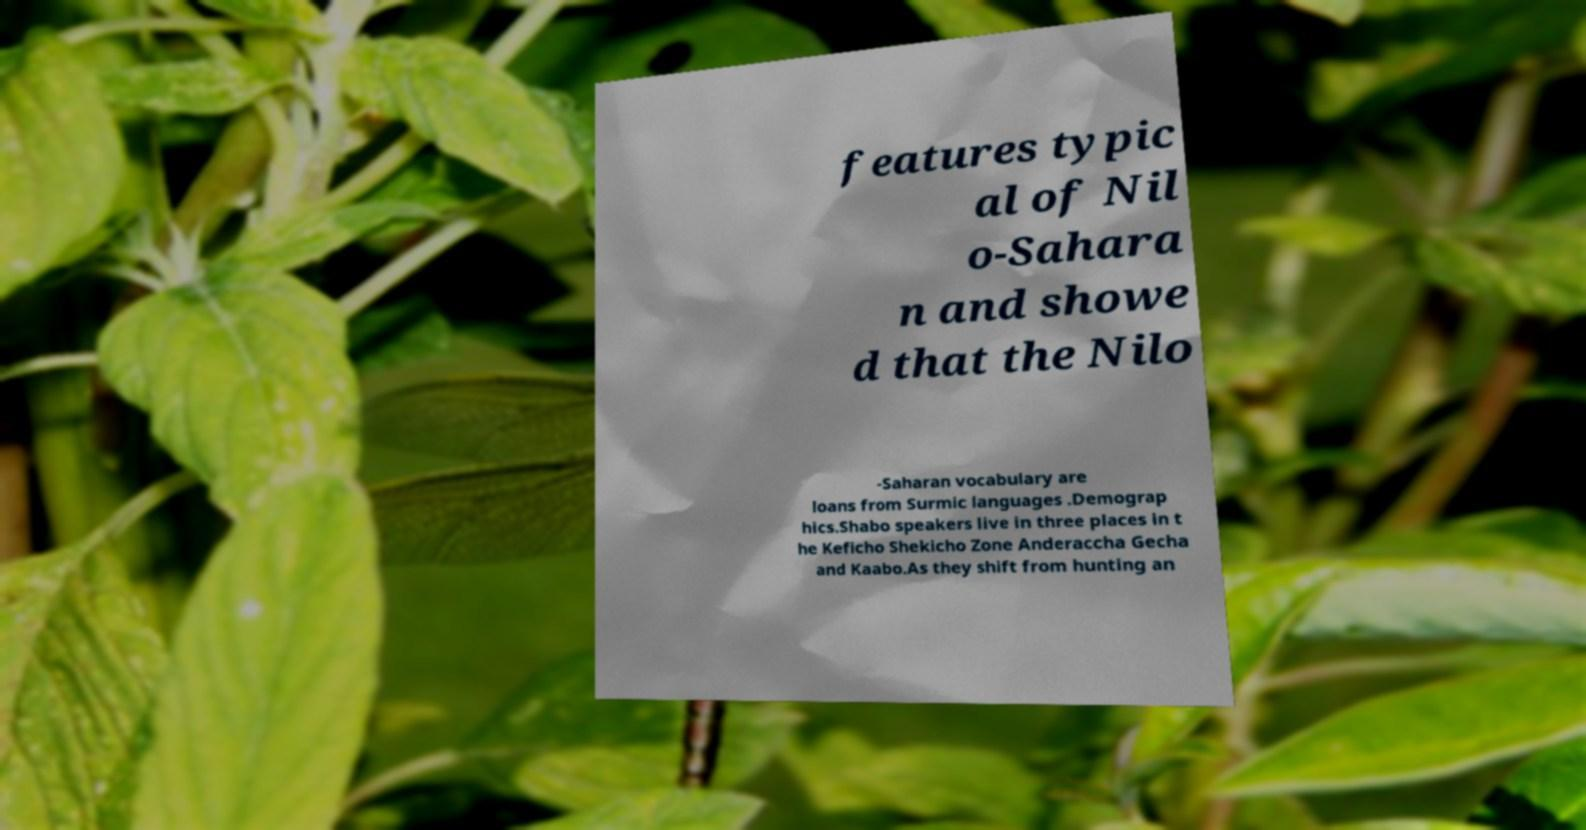Can you read and provide the text displayed in the image?This photo seems to have some interesting text. Can you extract and type it out for me? features typic al of Nil o-Sahara n and showe d that the Nilo -Saharan vocabulary are loans from Surmic languages .Demograp hics.Shabo speakers live in three places in t he Keficho Shekicho Zone Anderaccha Gecha and Kaabo.As they shift from hunting an 